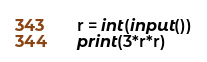Convert code to text. <code><loc_0><loc_0><loc_500><loc_500><_Python_>r = int(input())
print(3*r*r)</code> 